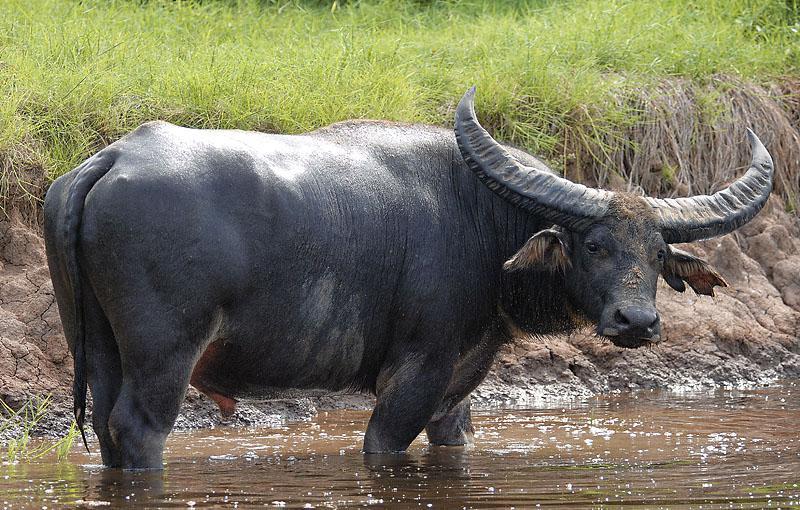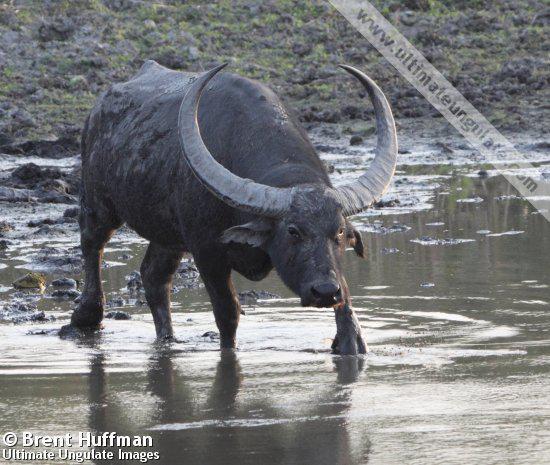The first image is the image on the left, the second image is the image on the right. Examine the images to the left and right. Is the description "Water bufallos are standing in water." accurate? Answer yes or no. Yes. The first image is the image on the left, the second image is the image on the right. Given the left and right images, does the statement "All images show water buffalo in the water." hold true? Answer yes or no. Yes. 